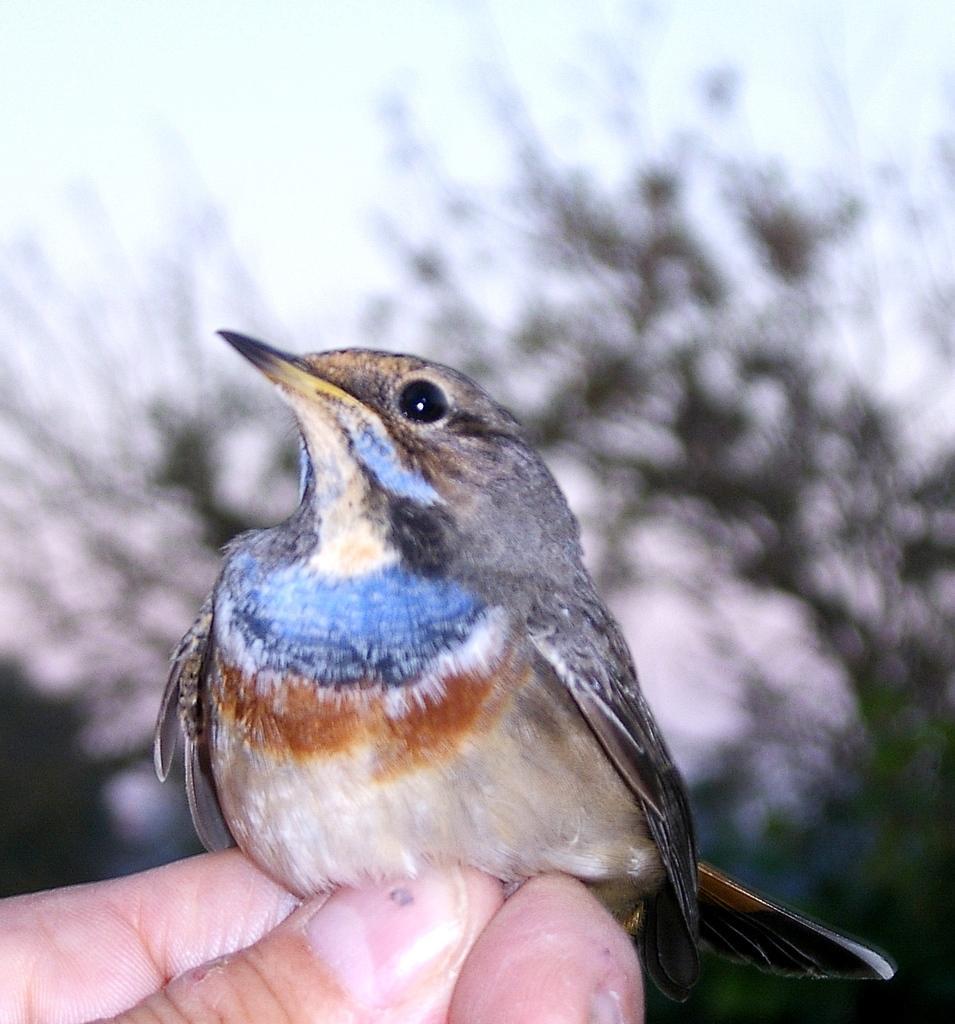In one or two sentences, can you explain what this image depicts? In this picture there is a person holding the bird. At the back there is a tree. At the top there is sky and the bird is in blue, orange, brown and in cream color. 